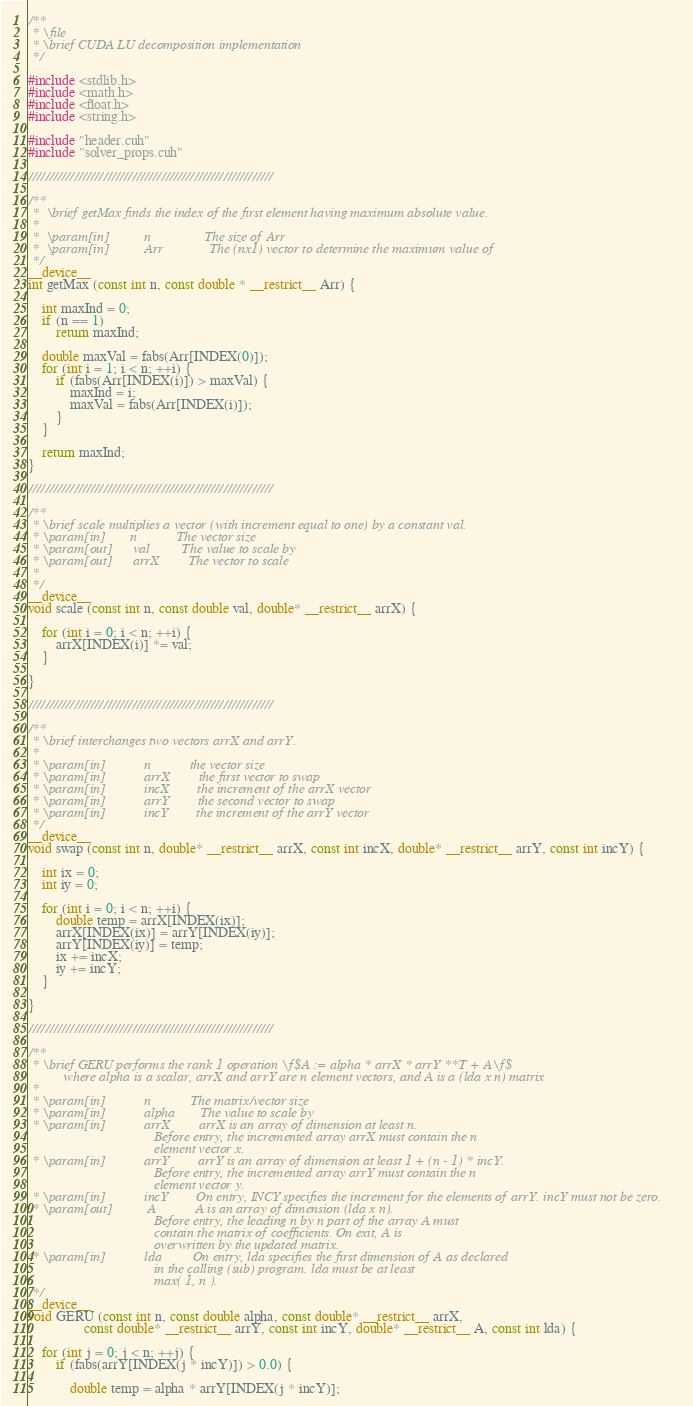<code> <loc_0><loc_0><loc_500><loc_500><_Cuda_>/**
 * \file
 * \brief CUDA LU decomposition implementation
 */

#include <stdlib.h>
#include <math.h>
#include <float.h>
#include <string.h>

#include "header.cuh"
#include "solver_props.cuh"

///////////////////////////////////////////////////////////

/**
 *  \brief getMax finds the index of the first element having maximum absolute value.
 *
 *  \param[in]          n               The size of Arr
 *  \param[in]          Arr      		The (nx1) vector to determine the maximum value of
 */
__device__
int getMax (const int n, const double * __restrict__ Arr) {

	int maxInd = 0;
	if (n == 1)
		return maxInd;

	double maxVal = fabs(Arr[INDEX(0)]);
	for (int i = 1; i < n; ++i) {
		if (fabs(Arr[INDEX(i)]) > maxVal) {
			maxInd = i;
			maxVal = fabs(Arr[INDEX(i)]);
		}
	}

	return maxInd;
}

///////////////////////////////////////////////////////////

/**
 * \brief scale multiplies a vector (with increment equal to one) by a constant val.
 * \param[in]       n           The vector size
 * \param[out]      val         The value to scale by
 * \param[out]      arrX        The vector to scale
 *
 */
__device__
void scale (const int n, const double val, double* __restrict__ arrX) {

	for (int i = 0; i < n; ++i) {
		arrX[INDEX(i)] *= val;
	}

}

///////////////////////////////////////////////////////////

/**
 * \brief interchanges two vectors arrX and arrY.
 *
 * \param[in]			n			the vector size
 * \param[in]			arrX		the first vector to swap
 * \param[in]			incX		the increment of the arrX vector
 * \param[in]			arrY		the second vector to swap
 * \param[in]			incY		the increment of the arrY vector
 */
__device__
void swap (const int n, double* __restrict__ arrX, const int incX, double* __restrict__ arrY, const int incY) {

	int ix = 0;
	int iy = 0;

	for (int i = 0; i < n; ++i) {
		double temp = arrX[INDEX(ix)];
		arrX[INDEX(ix)] = arrY[INDEX(iy)];
		arrY[INDEX(iy)] = temp;
		ix += incX;
		iy += incY;
	}

}

///////////////////////////////////////////////////////////

/**
 * \brief GERU performs the rank 1 operation \f$A := alpha * arrX * arrY **T + A\f$
          where alpha is a scalar, arrX and arrY are n element vectors, and A is a (lda x n) matrix
 *
 * \param[in]           n           The matrix/vector size
 * \param[in]           alpha       The value to scale by
 * \param[in]           arrX        arrX is an array of dimension at least n.
                                    Before entry, the incremented array arrX must contain the n
                                    element vector x.
 * \param[in]           arrY        arrY is an array of dimension at least 1 + (n - 1) * incY.
                                    Before entry, the incremented array arrY must contain the n
                                    element vector y.
 * \param[in]           incY        On entry, INCY specifies the increment for the elements of arrY. incY must not be zero.
 * \param[out]          A           A is an array of dimension (lda x n).
                                    Before entry, the leading n by n part of the array A must
                                    contain the matrix of coefficients. On exit, A is
                                    overwritten by the updated matrix.
 * \param[in]           lda         On entry, lda specifies the first dimension of A as declared
                                    in the calling (sub) program. lda must be at least
                                    max( 1, n ).
 */
__device__
void GERU (const int n, const double alpha, const double* __restrict__ arrX,
				const double* __restrict__ arrY, const int incY, double* __restrict__ A, const int lda) {

	for (int j = 0; j < n; ++j) {
    	if (fabs(arrY[INDEX(j * incY)]) > 0.0) {

			double temp = alpha * arrY[INDEX(j * incY)];
</code> 